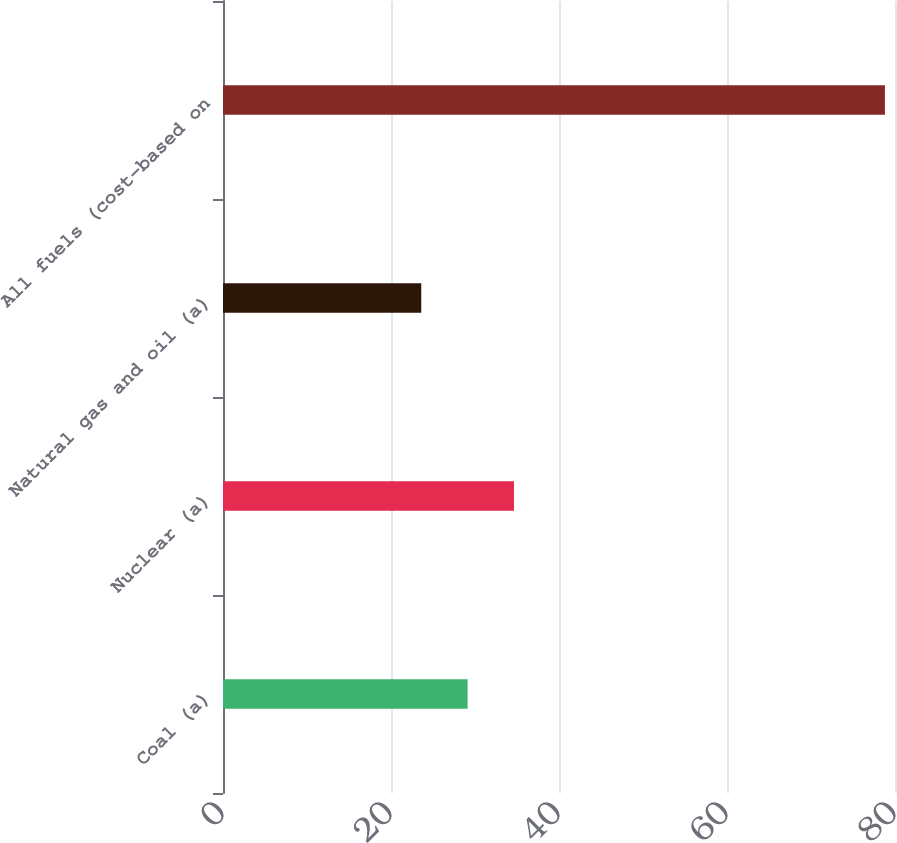Convert chart to OTSL. <chart><loc_0><loc_0><loc_500><loc_500><bar_chart><fcel>Coal (a)<fcel>Nuclear (a)<fcel>Natural gas and oil (a)<fcel>All fuels (cost-based on<nl><fcel>29.12<fcel>34.64<fcel>23.6<fcel>78.8<nl></chart> 